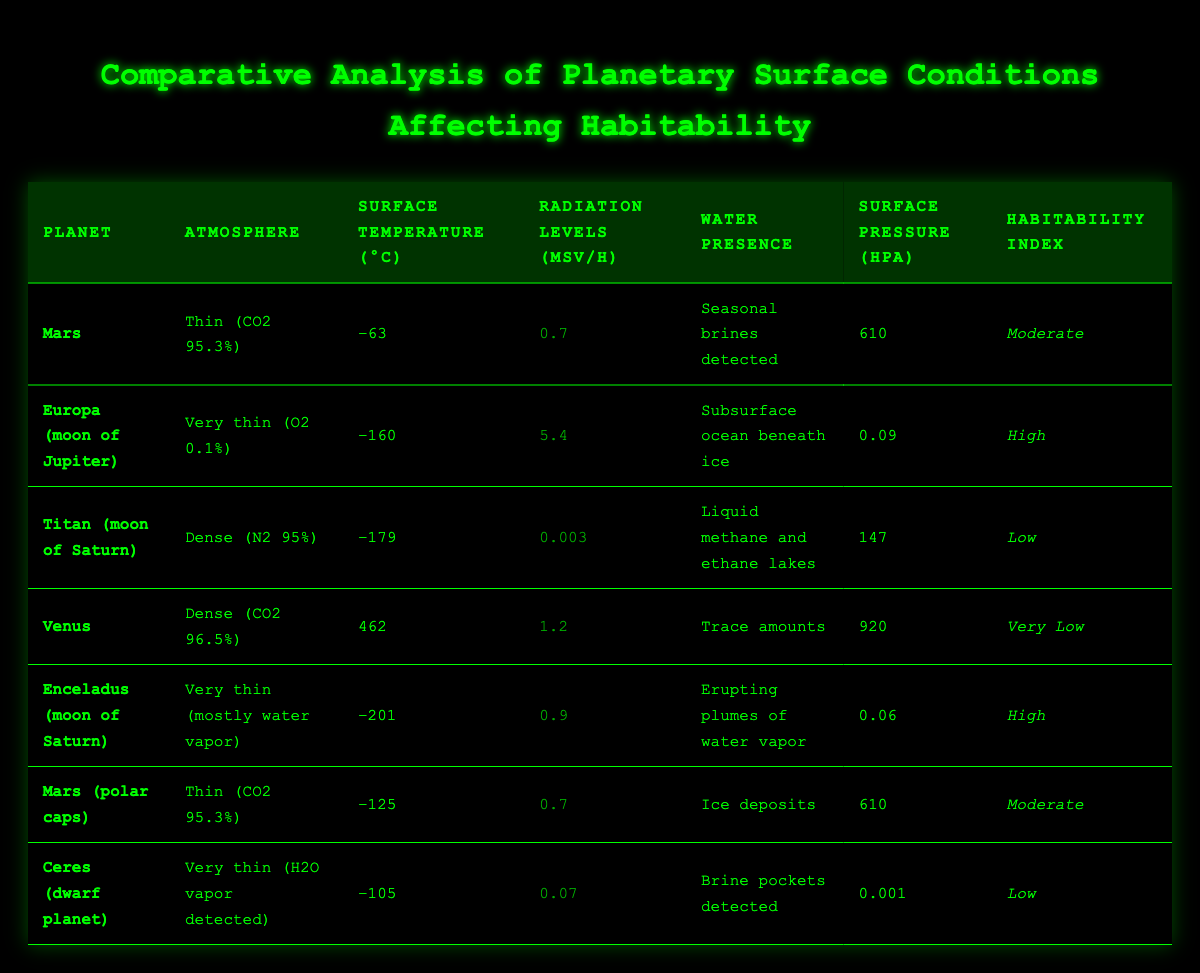What is the habitability index of Mars? The habitability index for Mars is listed in the table. It states "Moderate" next to Mars in the Habitability Index column.
Answer: Moderate Which planet has the highest radiation levels? Looking at the Radiation Levels column, Europa has the highest measurement at 5.4 µSv/h.
Answer: Europa What is the surface pressure of Venus? The table lists Venus with a surface pressure of 920 hPa under the Surface Pressure column.
Answer: 920 hPa How many planets have a "High" habitability index? By scanning the Habitability Index column, we find that both Europa and Enceladus are rated "High," totaling two planets with that rating.
Answer: 2 What is the surface temperature of Titan? In the Surface Temperature (°C) column, Titan is listed with a temperature of −179 °C.
Answer: −179 °C Is there water presence detected on Ceres? The table indicates that Ceres has "Brine pockets detected" under the Water Presence column, confirming the presence of water.
Answer: Yes Calculate the average surface temperature of the planets shown. The surface temperatures are −63, −160, −179, 462, −201, −125, and −105 °C. First, we sum them: (−63 − 160 − 179 + 462 − 201 − 125 − 105) = −371. There are 7 data points, so the average is −371 / 7 ≈ −53. Therefore, the average surface temperature is approximately −53 °C.
Answer: −53 °C Which planet has the lowest radiation levels? The table shows that Titan has the lowest radiation level at 0.003 µSv/h in the Radiation Levels column.
Answer: Titan How does the surface temperature of Europa compare to Mars? Europa's surface temperature is −160 °C, while Mars is −63 °C. Comparing these values shows that Europa is significantly colder than Mars by 97 °C.
Answer: Europa is colder by 97 °C What is the surface pressure of Enceladus? Enceladus has a surface pressure listed as 0.06 hPa in the Surface Pressure column of the table.
Answer: 0.06 hPa 